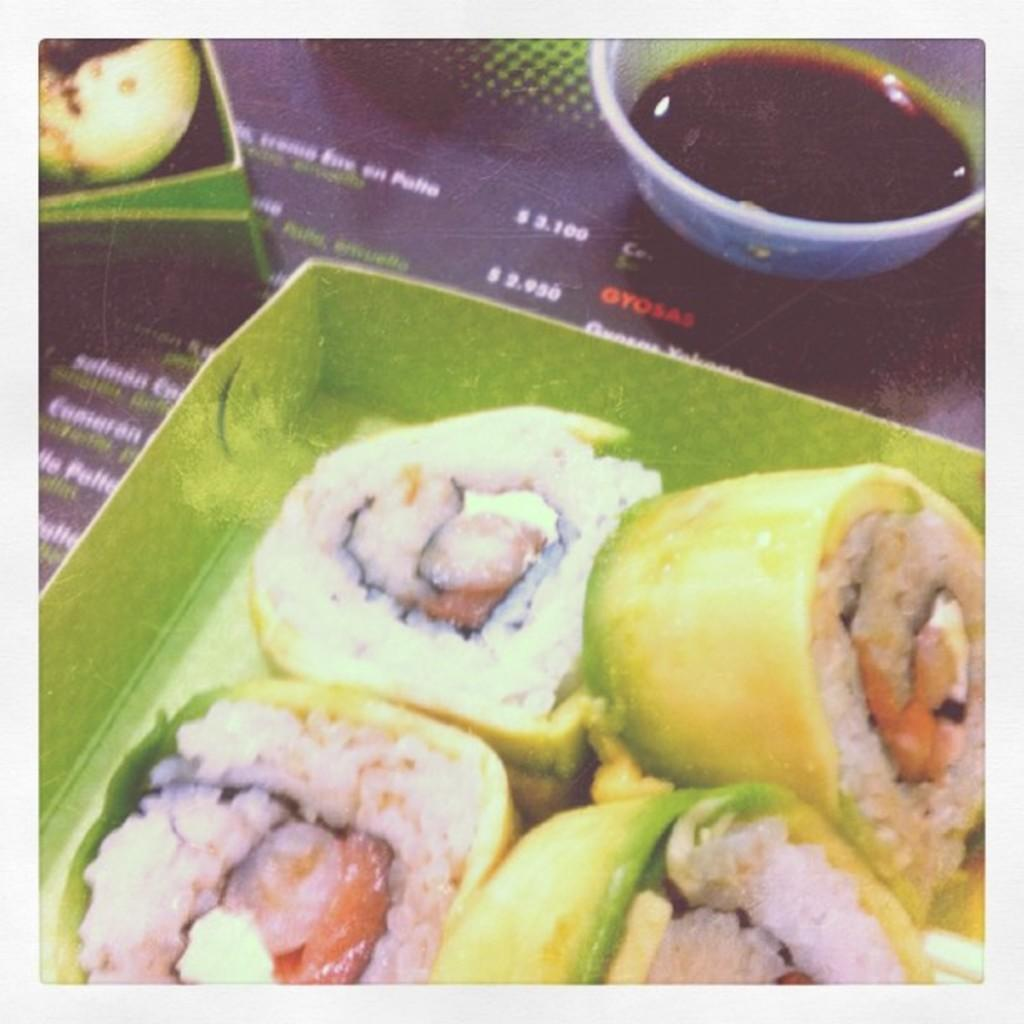What is the primary object in the image? There is a menu card in the image. What else can be seen in the image besides the menu card? There is a bowl, boxes, and food visible in the image. What might the food be served in? The food might be served in the bowl or the boxes. What type of sign can be seen in the image? There is no sign present in the image. Can you see the moon in the image? The image does not depict the moon; it features a menu card, a bowl, boxes, and food. 